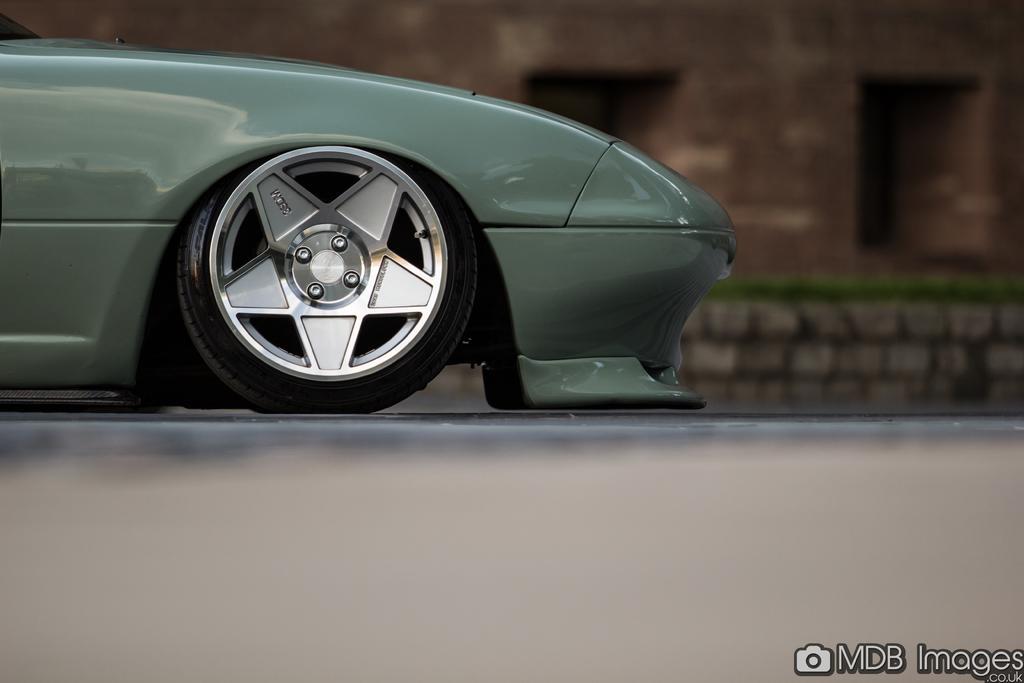In one or two sentences, can you explain what this image depicts? In this picture we can see a wheel of a vehicle on the platform and in the background we can see a wall and some objects, in the bottom right we can see some text on it. 